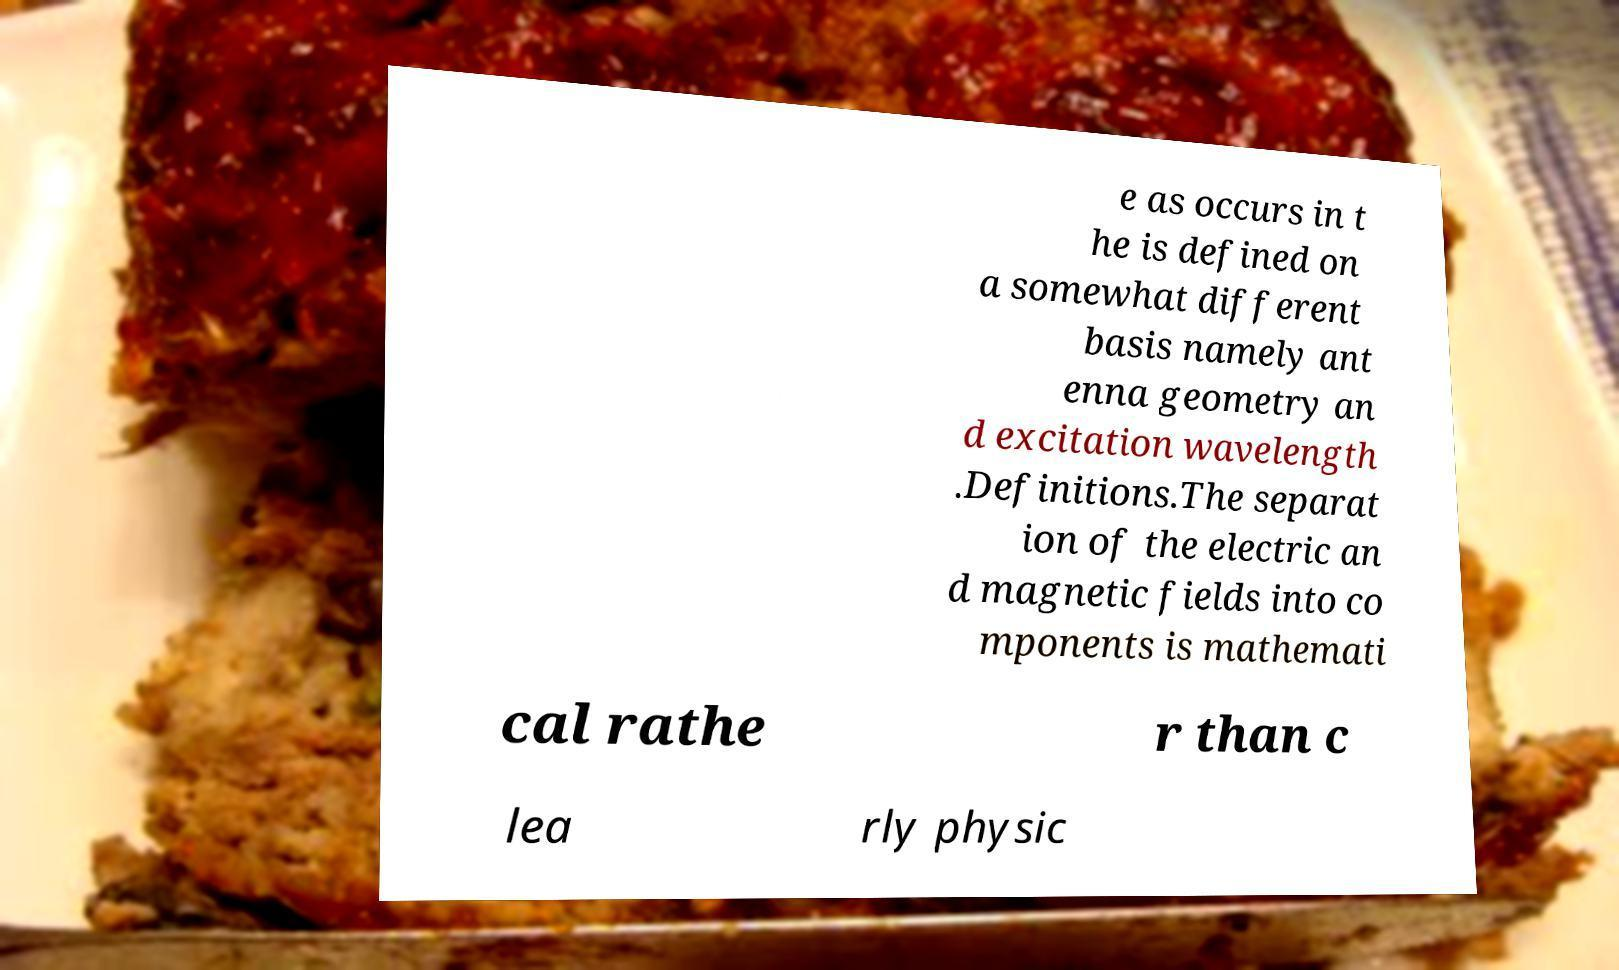What messages or text are displayed in this image? I need them in a readable, typed format. e as occurs in t he is defined on a somewhat different basis namely ant enna geometry an d excitation wavelength .Definitions.The separat ion of the electric an d magnetic fields into co mponents is mathemati cal rathe r than c lea rly physic 